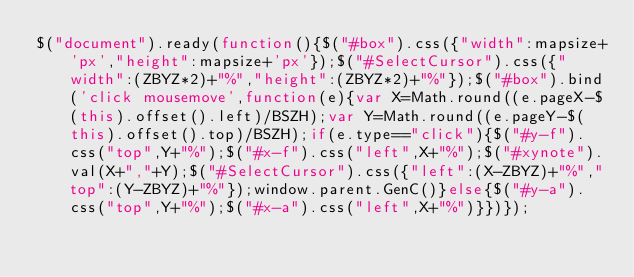Convert code to text. <code><loc_0><loc_0><loc_500><loc_500><_JavaScript_>$("document").ready(function(){$("#box").css({"width":mapsize+'px',"height":mapsize+'px'});$("#SelectCursor").css({"width":(ZBYZ*2)+"%","height":(ZBYZ*2)+"%"});$("#box").bind('click mousemove',function(e){var X=Math.round((e.pageX-$(this).offset().left)/BSZH);var Y=Math.round((e.pageY-$(this).offset().top)/BSZH);if(e.type=="click"){$("#y-f").css("top",Y+"%");$("#x-f").css("left",X+"%");$("#xynote").val(X+","+Y);$("#SelectCursor").css({"left":(X-ZBYZ)+"%","top":(Y-ZBYZ)+"%"});window.parent.GenC()}else{$("#y-a").css("top",Y+"%");$("#x-a").css("left",X+"%")}})});</code> 